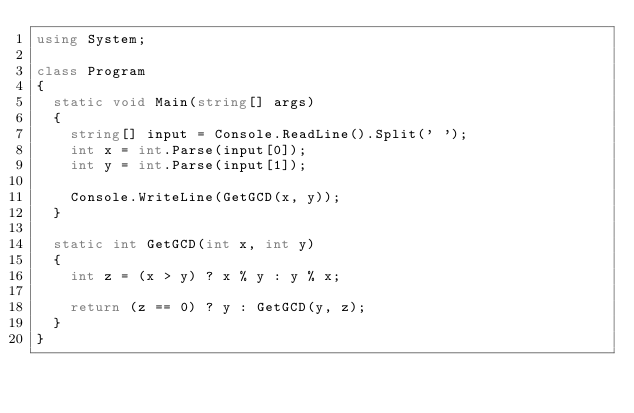<code> <loc_0><loc_0><loc_500><loc_500><_C#_>using System;

class Program
{
	static void Main(string[] args)
	{
		string[] input = Console.ReadLine().Split(' ');
		int x = int.Parse(input[0]);
		int y = int.Parse(input[1]);

		Console.WriteLine(GetGCD(x, y));
	}

	static int GetGCD(int x, int y)
	{
		int z = (x > y) ? x % y : y % x;

		return (z == 0) ? y : GetGCD(y, z);
	}
}</code> 